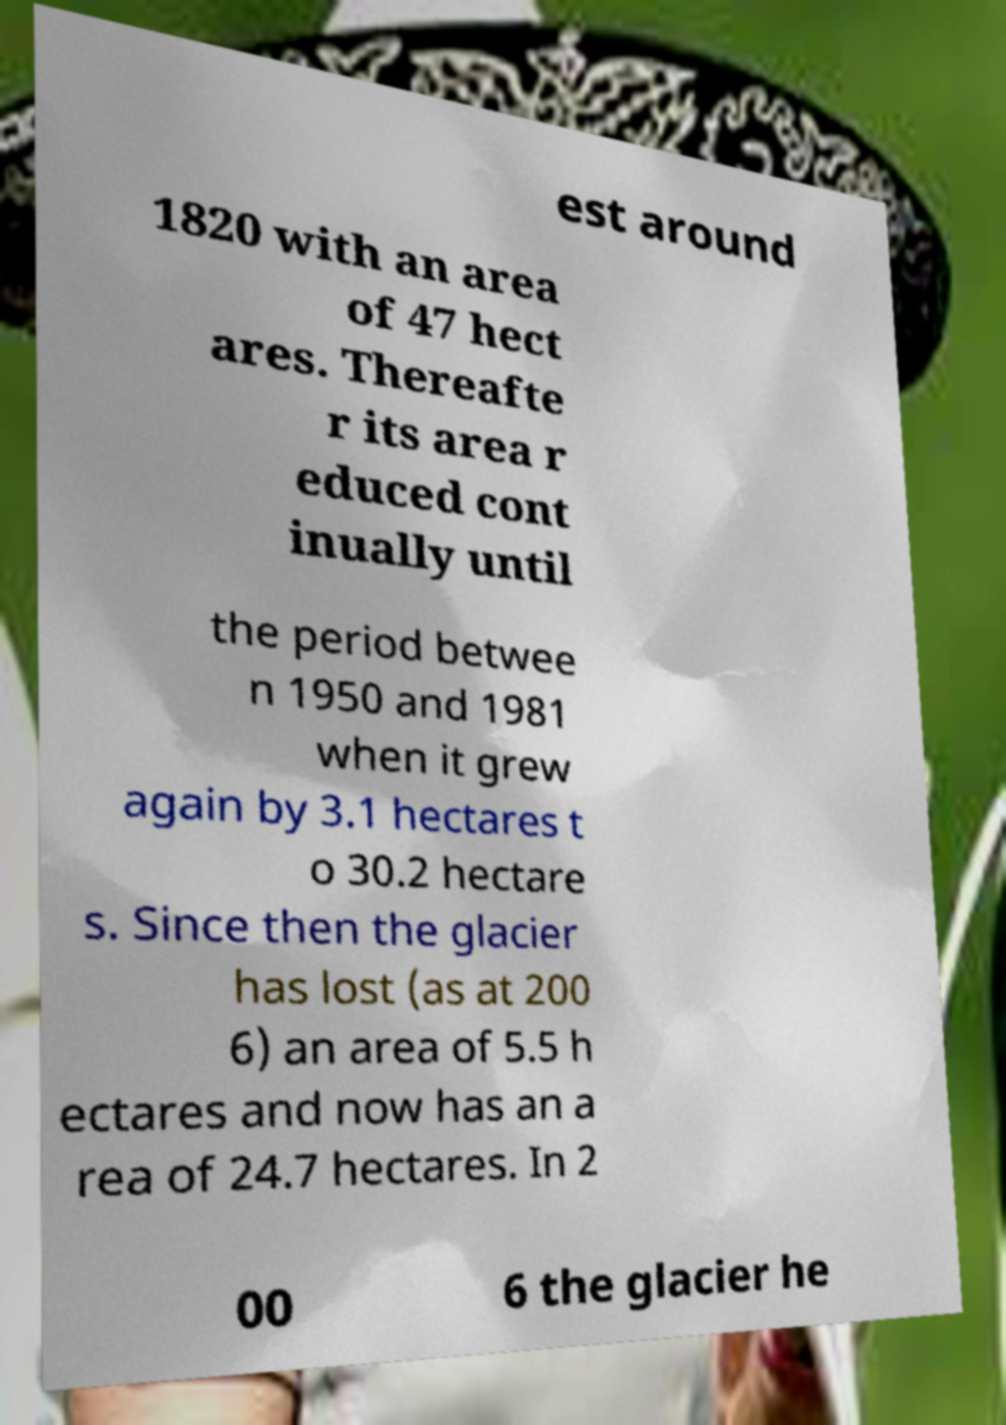There's text embedded in this image that I need extracted. Can you transcribe it verbatim? est around 1820 with an area of 47 hect ares. Thereafte r its area r educed cont inually until the period betwee n 1950 and 1981 when it grew again by 3.1 hectares t o 30.2 hectare s. Since then the glacier has lost (as at 200 6) an area of 5.5 h ectares and now has an a rea of 24.7 hectares. In 2 00 6 the glacier he 